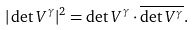<formula> <loc_0><loc_0><loc_500><loc_500>| \det V ^ { \gamma } | ^ { 2 } = \det V ^ { \gamma } \cdot \overline { \det V ^ { \gamma } } .</formula> 